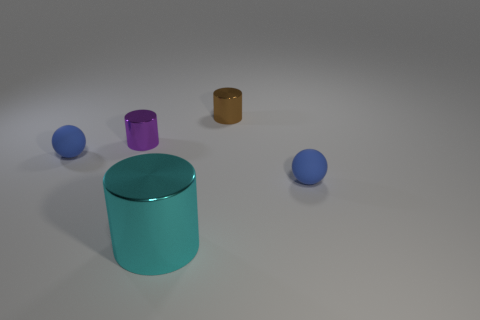Add 5 small gray shiny objects. How many objects exist? 10 Subtract all cylinders. How many objects are left? 2 Add 3 tiny brown metallic cylinders. How many tiny brown metallic cylinders are left? 4 Add 4 big cyan metal things. How many big cyan metal things exist? 5 Subtract 2 blue balls. How many objects are left? 3 Subtract all large brown balls. Subtract all small rubber spheres. How many objects are left? 3 